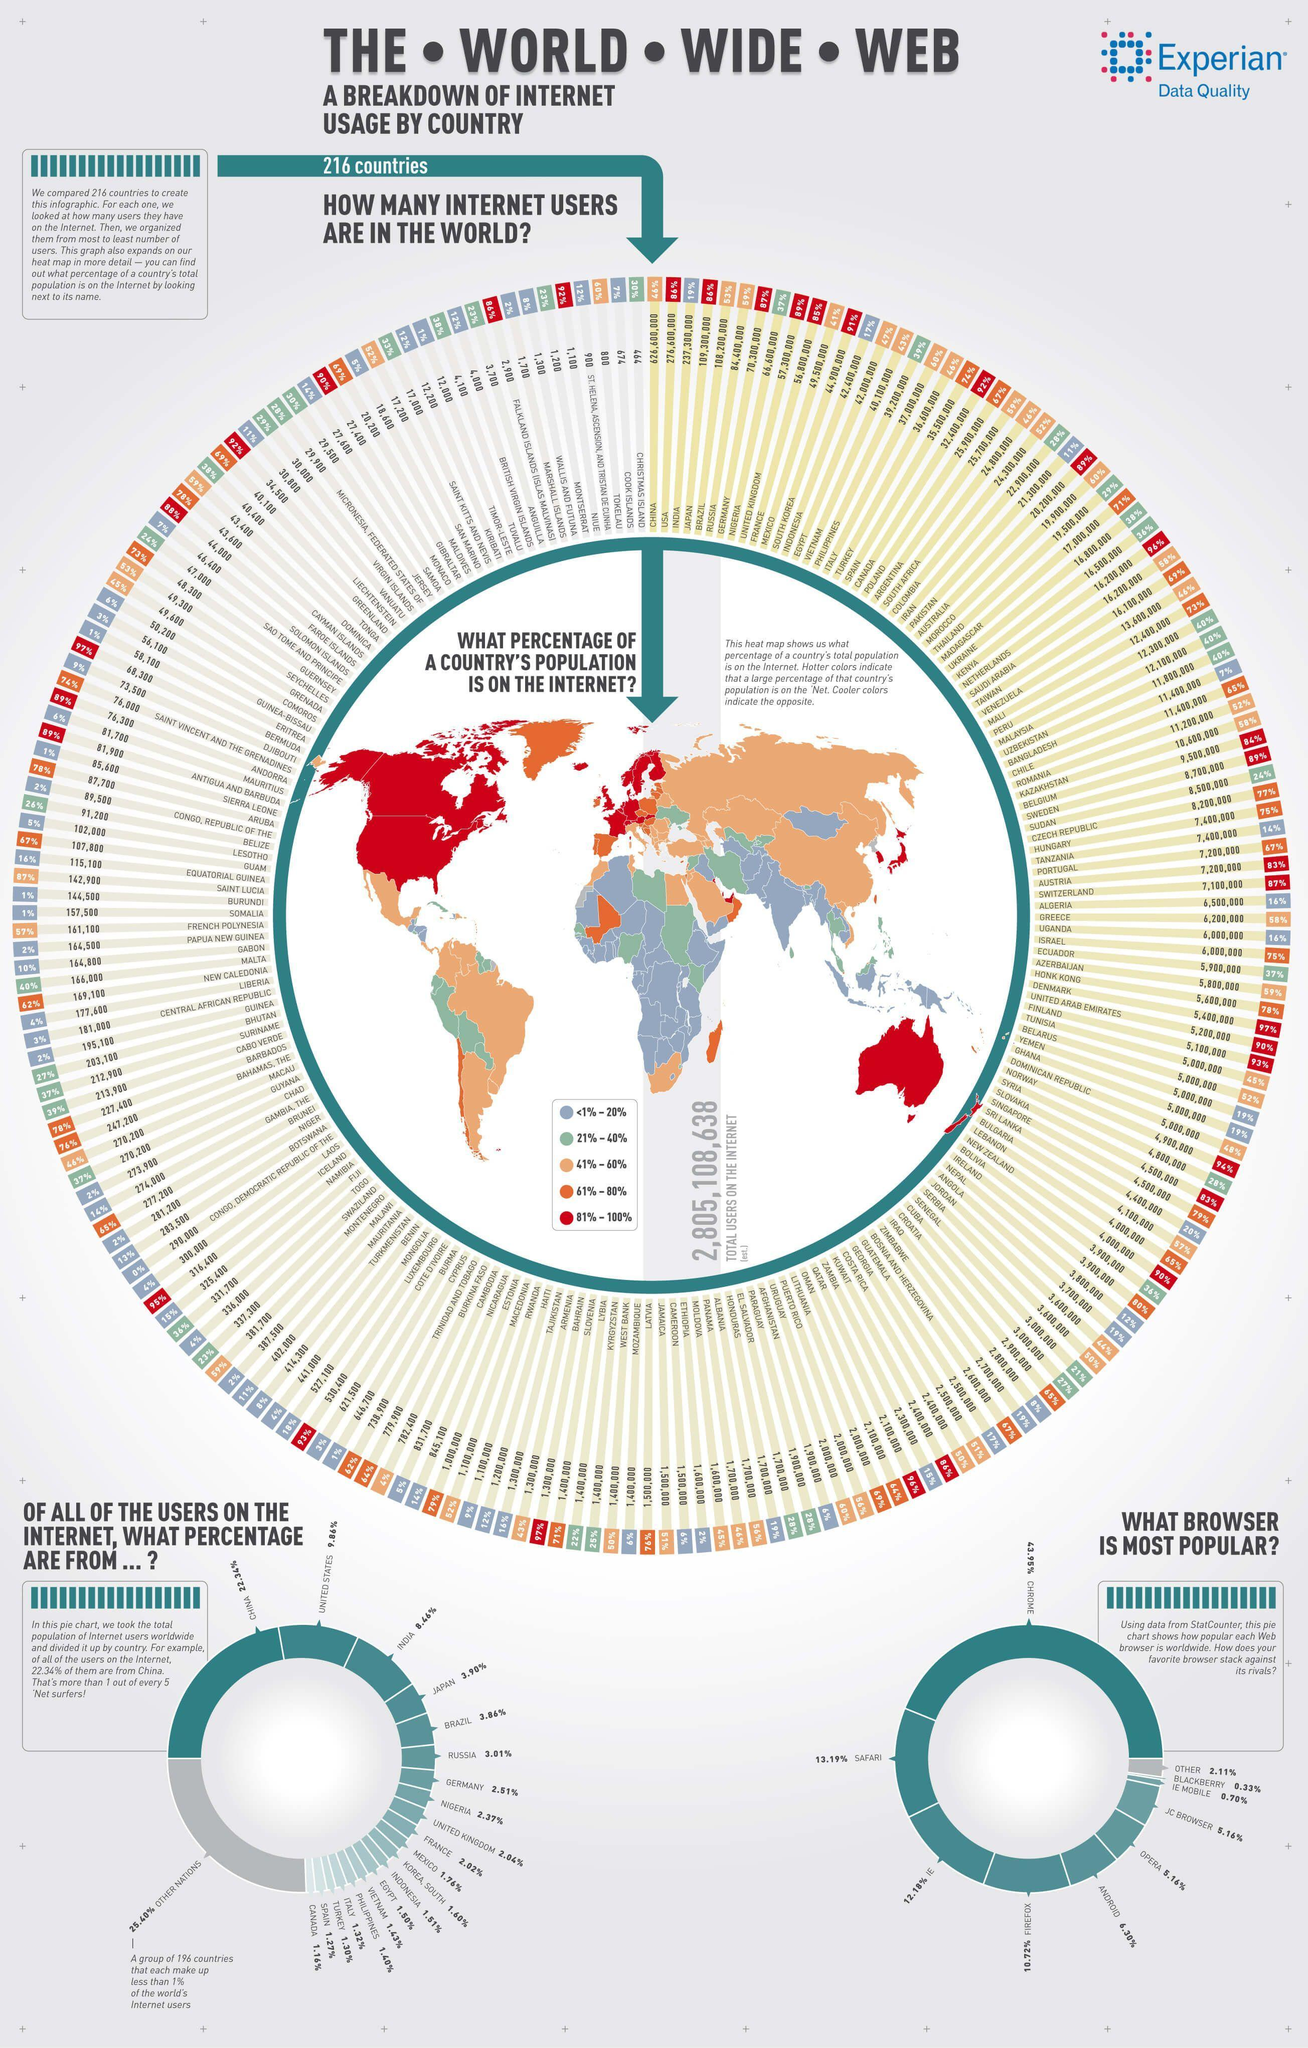How many countries make up for more than 1% of internet users in the world?
Answer the question with a short phrase. 20 What is the difference in percentage of users using the browsers IE mobile and Blackberry? 0.37 Which country is has the higher percentage of internet users after Japan? Brazil Which country has the least amount of Internet users? Christmas Island Which color represents the second highest internet consuming countries in the world, red, blue, or orange? orange What is the difference in percentage of internet users in India and Japan? 4.56% What is percentage of internet user in United Kingdom? 89% Which two countries have 16,200,000 internet users  ? Kenya and Netherlands Which internet browser Safari, Internet explorer, or Chrome is the most used among the internet users? Chrome What is percentage of internet user in Bhutan? 27% 